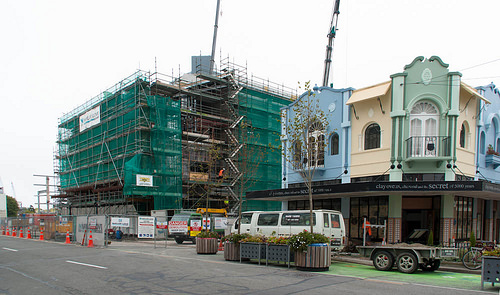<image>
Can you confirm if the building is in front of the car? Yes. The building is positioned in front of the car, appearing closer to the camera viewpoint. 